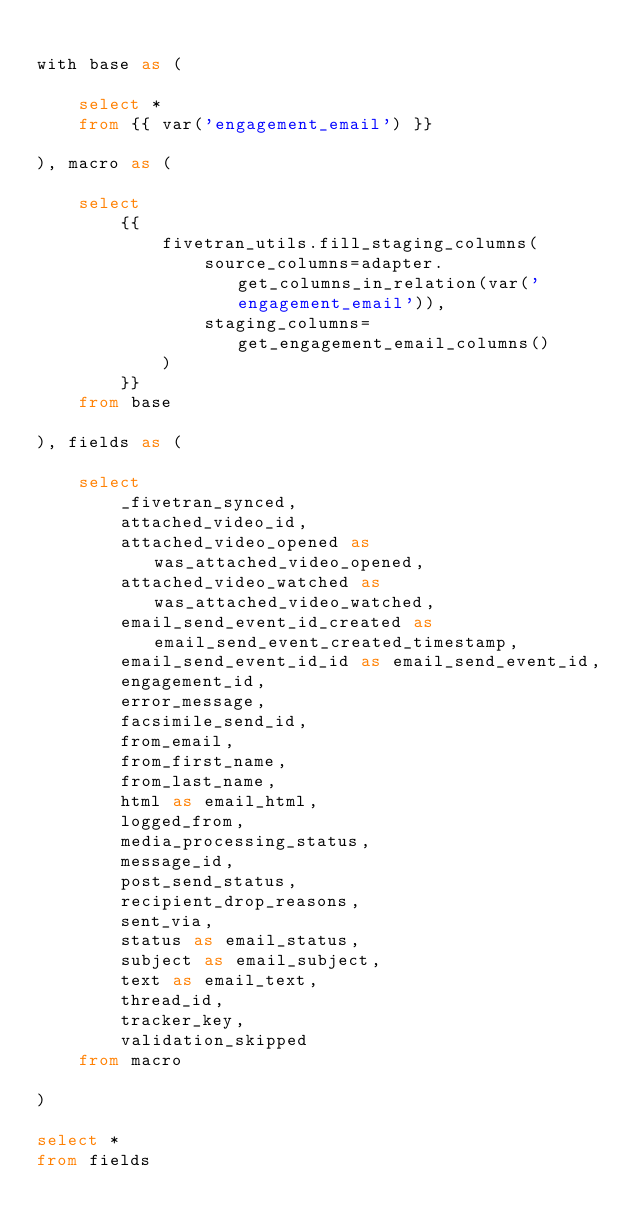<code> <loc_0><loc_0><loc_500><loc_500><_SQL_>
with base as (

    select *
    from {{ var('engagement_email') }}

), macro as (

    select
        {{
            fivetran_utils.fill_staging_columns(
                source_columns=adapter.get_columns_in_relation(var('engagement_email')),
                staging_columns=get_engagement_email_columns()
            )
        }}
    from base

), fields as (

    select
        _fivetran_synced,
        attached_video_id,
        attached_video_opened as was_attached_video_opened,
        attached_video_watched as was_attached_video_watched,
        email_send_event_id_created as email_send_event_created_timestamp,
        email_send_event_id_id as email_send_event_id,
        engagement_id,
        error_message,
        facsimile_send_id,
        from_email,
        from_first_name,
        from_last_name,
        html as email_html,
        logged_from,
        media_processing_status,
        message_id,
        post_send_status,
        recipient_drop_reasons,
        sent_via,
        status as email_status,
        subject as email_subject,
        text as email_text,
        thread_id,
        tracker_key,
        validation_skipped
    from macro

)

select *
from fields
</code> 